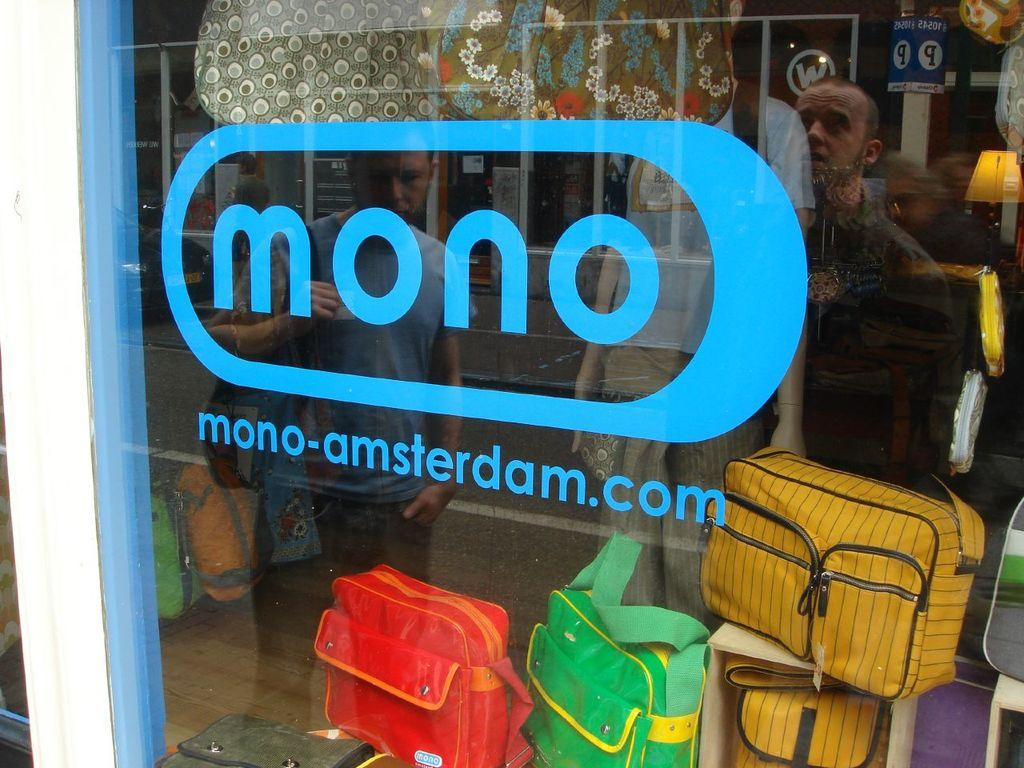What is the main feature in the foreground of the picture? There is a glass window in the foreground of the picture. What can be seen on the other side of the window? There are bags on the other side of the window. Can you describe what is visible in the reflection of the window? People are standing and visible in the reflection of the window. What type of tax is being discussed by the people in the reflection of the window? There is no indication in the image that the people in the reflection are discussing any type of tax. 